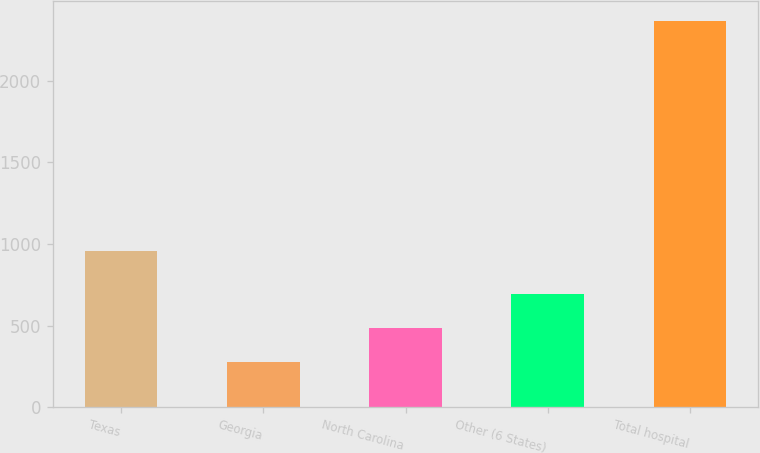Convert chart. <chart><loc_0><loc_0><loc_500><loc_500><bar_chart><fcel>Texas<fcel>Georgia<fcel>North Carolina<fcel>Other (6 States)<fcel>Total hospital<nl><fcel>959<fcel>274<fcel>483.4<fcel>692.8<fcel>2368<nl></chart> 